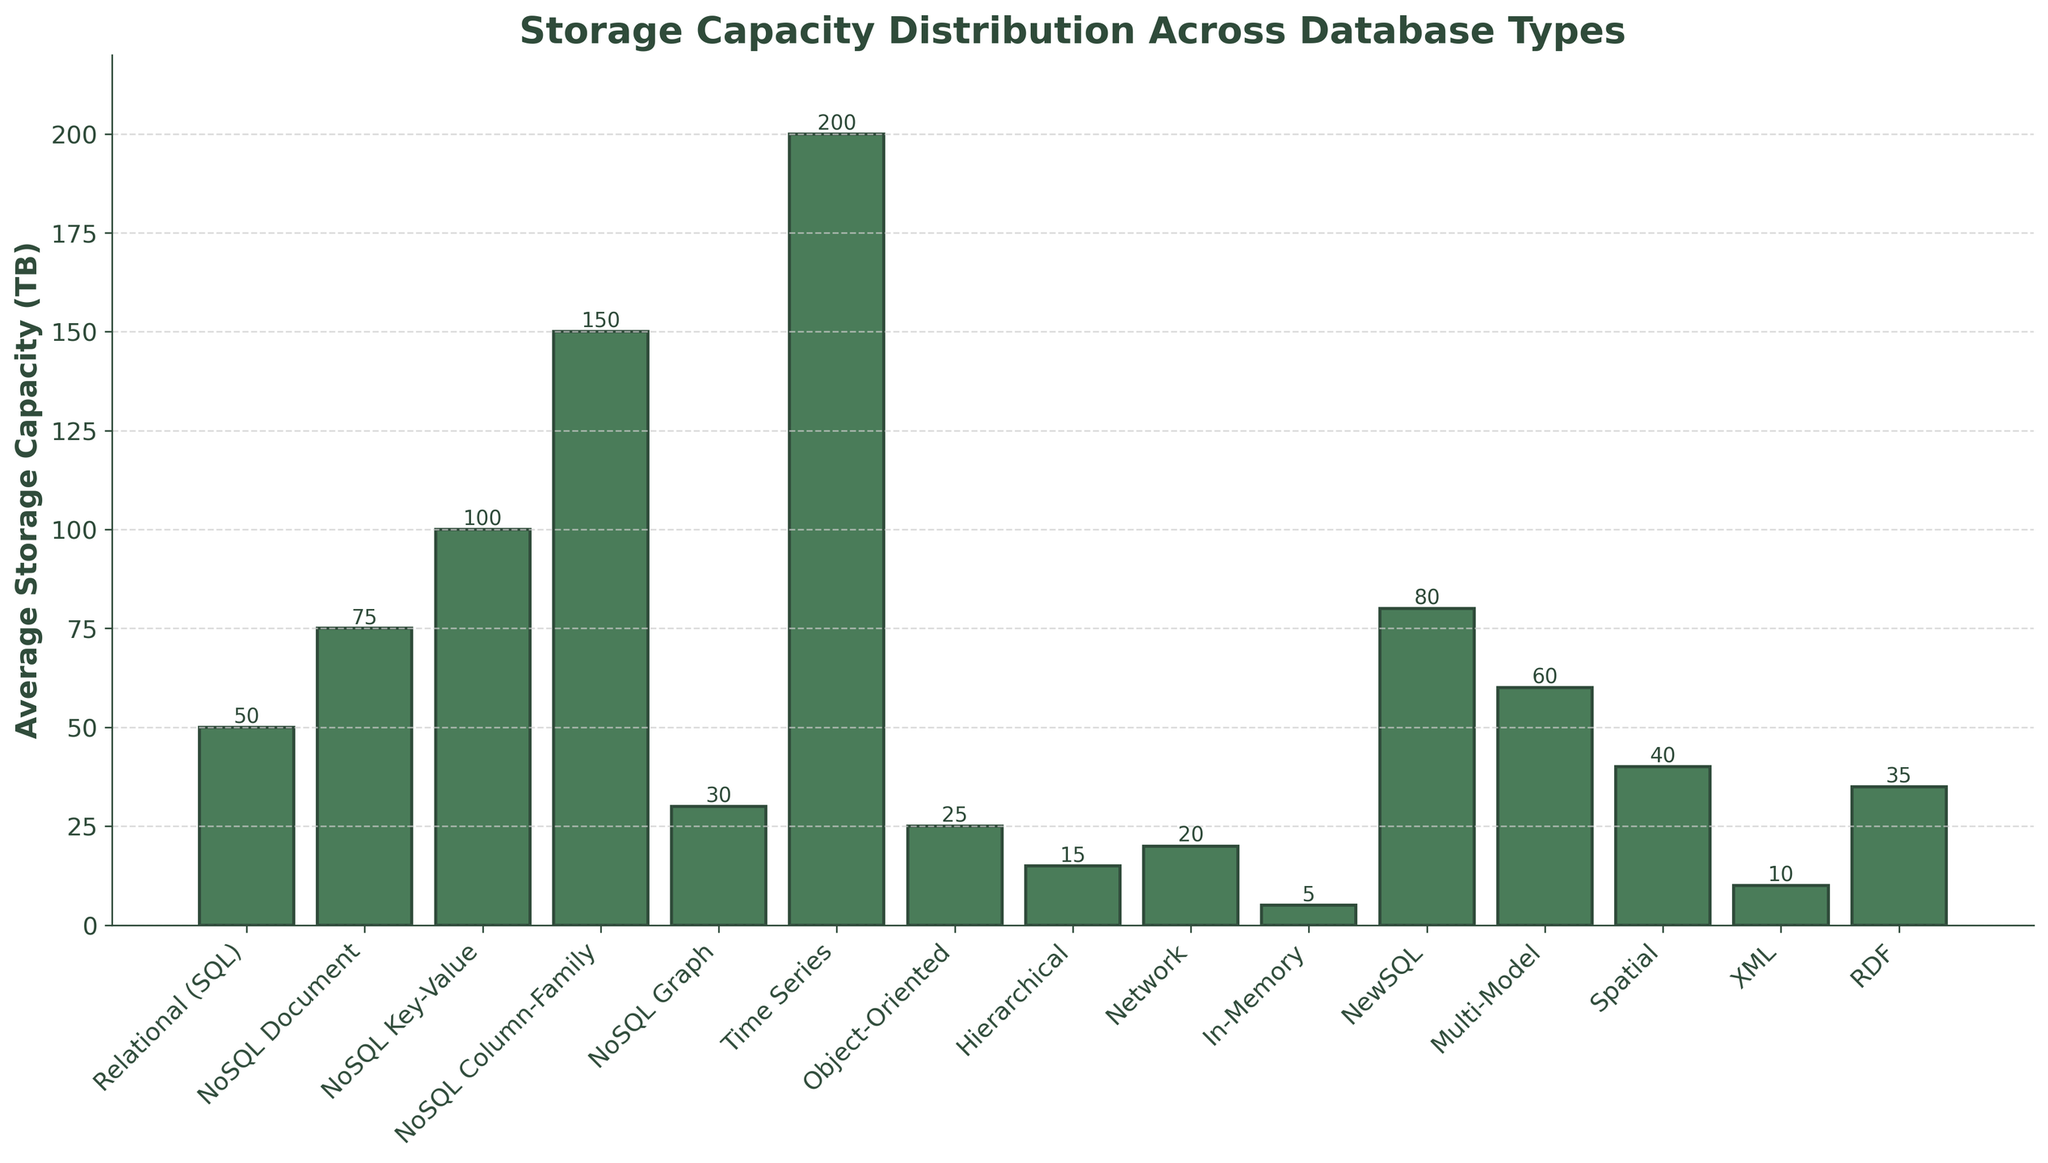Which database type has the highest storage capacity? Observe the bar with the greatest height. The time series database type has the highest bar, indicating the highest storage capacity.
Answer: Time Series Which database type has the lowest storage capacity? Look for the shortest bar in the chart. The in-memory database type has the shortest bar, indicating the lowest storage capacity.
Answer: In-Memory How much higher is the storage capacity of NoSQL Column-Family compared to Relational (SQL)? Subtract the storage capacity of Relational (SQL) from that of NoSQL Column-Family. NoSQL Column-Family (150 TB) - Relational (SQL) (50 TB) = 100 TB.
Answer: 100 TB What is the combined storage capacity of Object-Oriented and Network database types? Add the storage capacities of both types. Object-Oriented (25 TB) + Network (20 TB) = 45 TB.
Answer: 45 TB Which database type has a storage capacity closest to 30 TB? Identify the bar with a value closest to 30 TB. The NoSQL Graph type has a storage capacity of 30 TB.
Answer: NoSQL Graph How does the storage capacity of Spatial compare to XML? Compare the heights of the bars for Spatial and XML. Spatial (40 TB) is greater than XML (10 TB).
Answer: Spatial has higher capacity than XML How many database types have a storage capacity greater than 50 TB? Count the number of bars with heights greater than 50 TB. Time Series, NoSQL Column-Family, NewSQL, NoSQL Key-Value, NoSQL Document; there are 5 such database types.
Answer: 5 What is the difference in storage capacity between the highest and lowest capacity database types? Subtract the capacity of the lowest (In-Memory) from the highest (Time Series). Time Series (200 TB) - In-Memory (5 TB) = 195 TB.
Answer: 195 TB Which database type has a storage capacity equal to 80 TB? Check for the bar that represents an 80 TB capacity value. NewSQL has a storage capacity of 80 TB.
Answer: NewSQL 